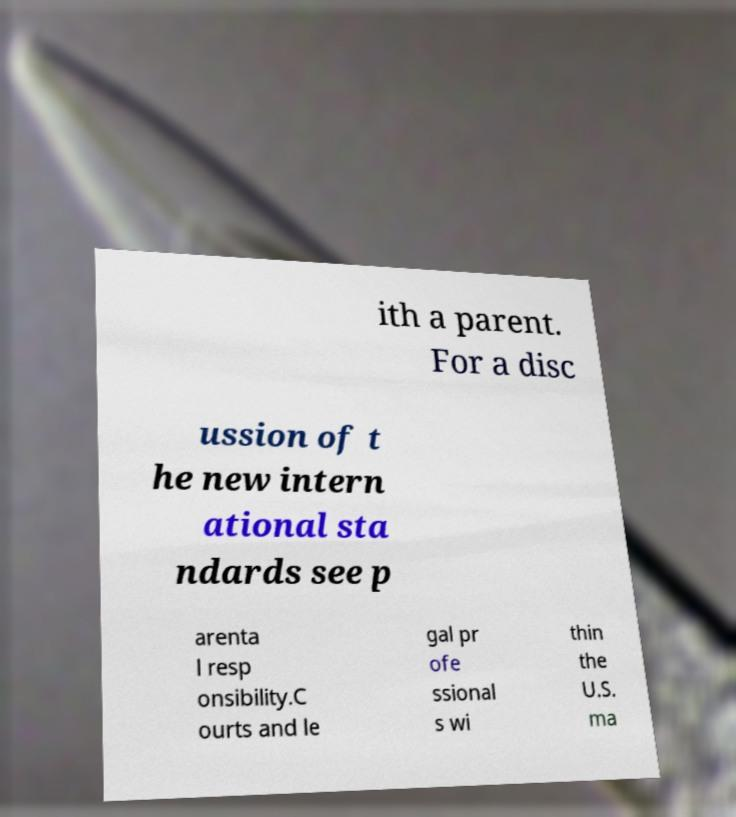Could you extract and type out the text from this image? ith a parent. For a disc ussion of t he new intern ational sta ndards see p arenta l resp onsibility.C ourts and le gal pr ofe ssional s wi thin the U.S. ma 